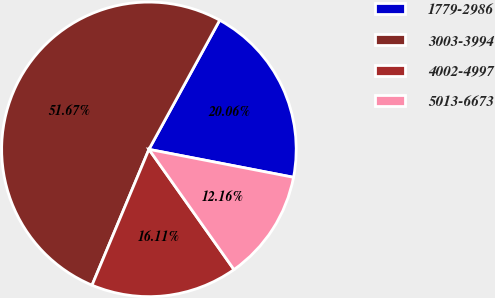<chart> <loc_0><loc_0><loc_500><loc_500><pie_chart><fcel>1779-2986<fcel>3003-3994<fcel>4002-4997<fcel>5013-6673<nl><fcel>20.06%<fcel>51.66%<fcel>16.11%<fcel>12.16%<nl></chart> 